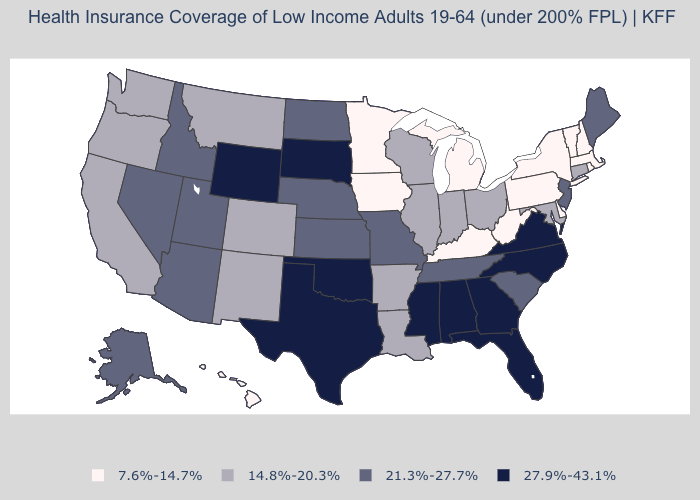Which states have the highest value in the USA?
Concise answer only. Alabama, Florida, Georgia, Mississippi, North Carolina, Oklahoma, South Dakota, Texas, Virginia, Wyoming. Name the states that have a value in the range 7.6%-14.7%?
Write a very short answer. Delaware, Hawaii, Iowa, Kentucky, Massachusetts, Michigan, Minnesota, New Hampshire, New York, Pennsylvania, Rhode Island, Vermont, West Virginia. What is the value of California?
Give a very brief answer. 14.8%-20.3%. What is the value of South Dakota?
Be succinct. 27.9%-43.1%. Does Wisconsin have the highest value in the MidWest?
Short answer required. No. Name the states that have a value in the range 14.8%-20.3%?
Give a very brief answer. Arkansas, California, Colorado, Connecticut, Illinois, Indiana, Louisiana, Maryland, Montana, New Mexico, Ohio, Oregon, Washington, Wisconsin. Does Minnesota have the lowest value in the USA?
Be succinct. Yes. Does Maine have the lowest value in the Northeast?
Keep it brief. No. Does West Virginia have the lowest value in the USA?
Keep it brief. Yes. How many symbols are there in the legend?
Give a very brief answer. 4. What is the highest value in the USA?
Short answer required. 27.9%-43.1%. Does Maine have the lowest value in the Northeast?
Answer briefly. No. What is the value of Illinois?
Answer briefly. 14.8%-20.3%. What is the highest value in the MidWest ?
Short answer required. 27.9%-43.1%. 